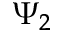<formula> <loc_0><loc_0><loc_500><loc_500>\Psi _ { 2 }</formula> 